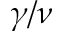Convert formula to latex. <formula><loc_0><loc_0><loc_500><loc_500>\gamma / \nu</formula> 